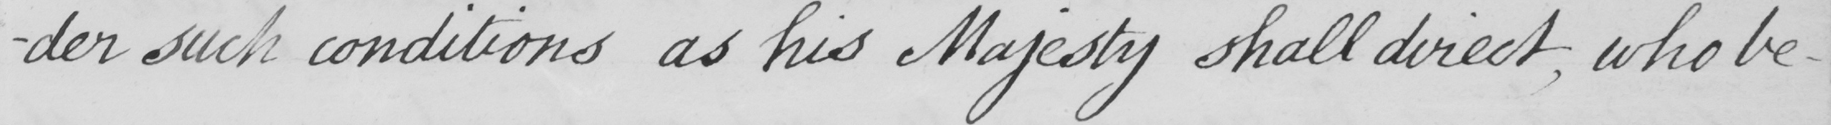Transcribe the text shown in this historical manuscript line. -der such conditions as his Majesty shall direct , who being 